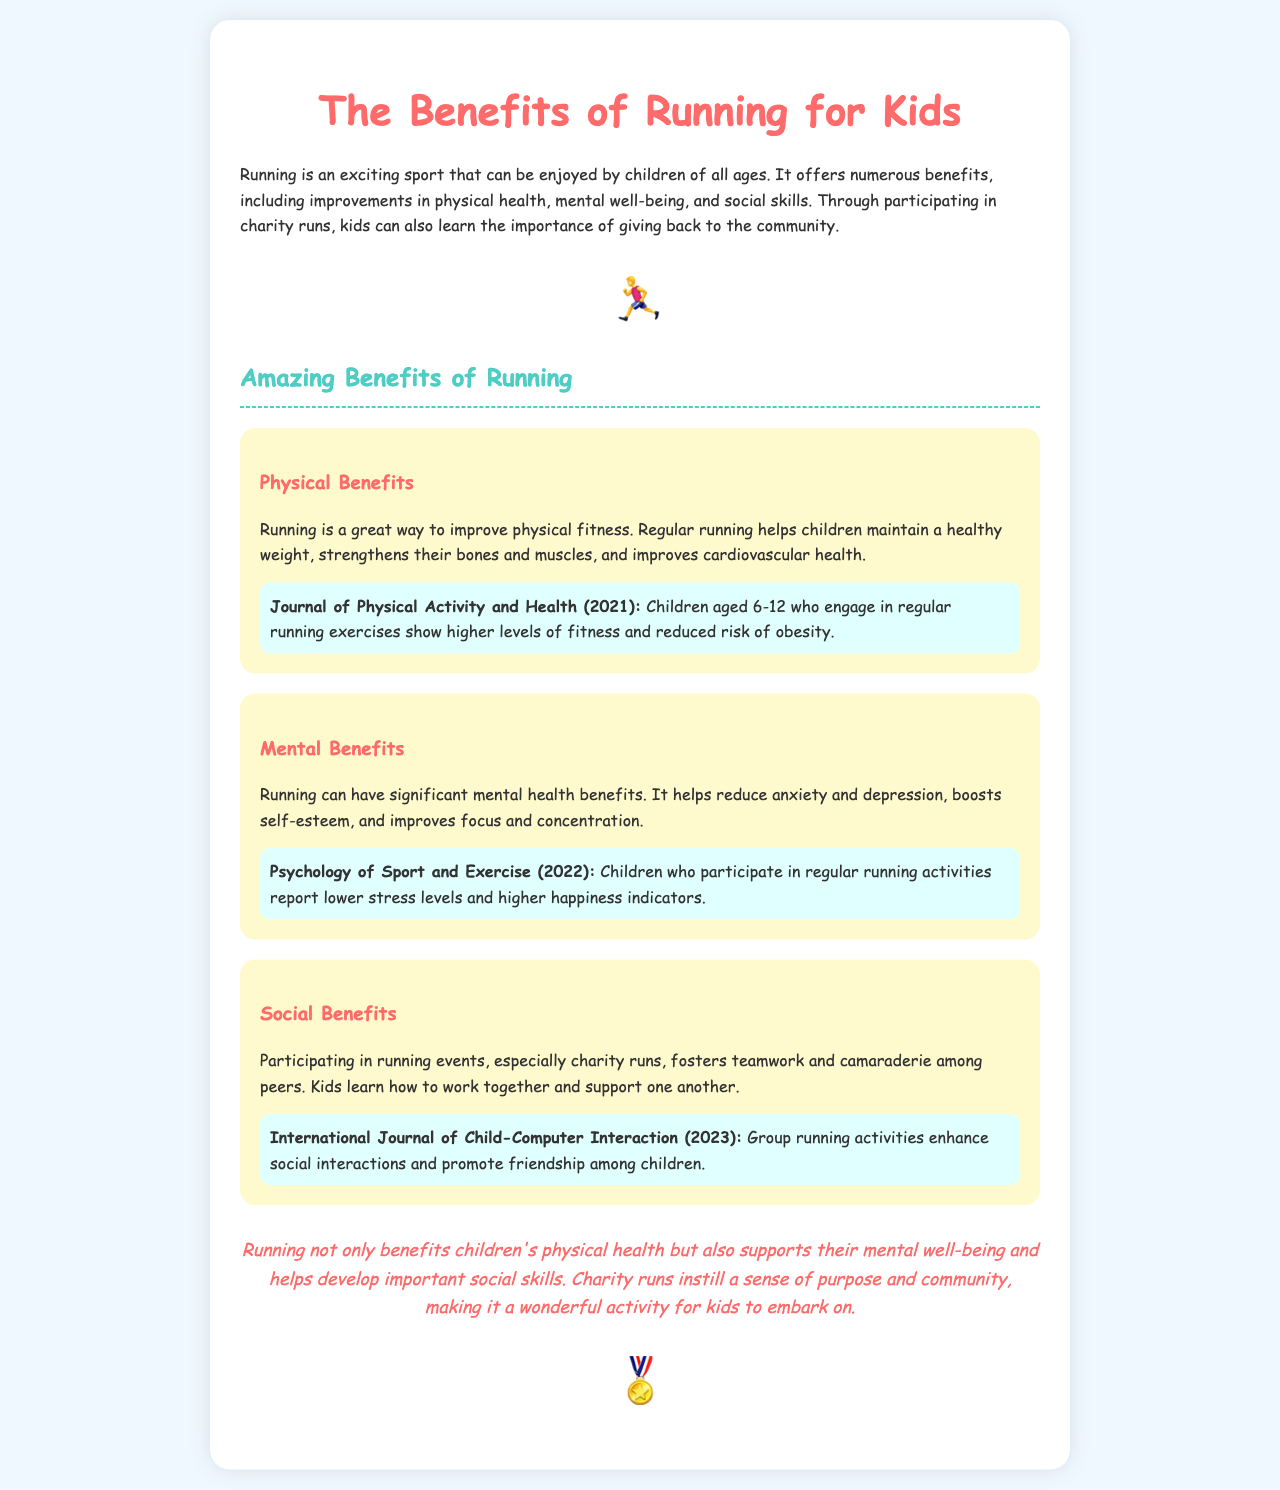What are the physical benefits of running? The document states that running improves physical fitness, helps maintain a healthy weight, strengthens bones and muscles, and improves cardiovascular health.
Answer: improve physical fitness What study supports the physical benefits of running? The report mentions a study published in the Journal of Physical Activity and Health in 2021, which discusses children's fitness levels.
Answer: Journal of Physical Activity and Health What can running reduce according to the mental benefits section? The mental benefits section states that running helps reduce anxiety and depression.
Answer: anxiety and depression What year was the study about mental benefits published? The document cites a study in Psychology of Sport and Exercise that was published in 2022.
Answer: 2022 How do charity runs help kids socially? The report explains that participating in charity runs fosters teamwork and camaraderie among peers.
Answer: fosters teamwork and camaraderie What is the main conclusion of the report? The conclusion summarizes the overall benefits of running for kids, highlighting its physical, mental, and social advantages.
Answer: benefits children's physical health What is the purpose of running according to the document? The document mentions that charity runs instill a sense of purpose and community for kids.
Answer: sense of purpose and community 